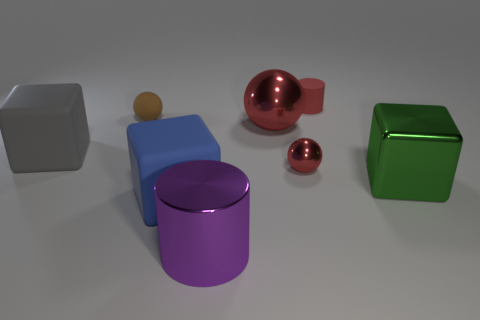There is another ball that is the same color as the tiny metal ball; what is its material?
Keep it short and to the point. Metal. How many gray things are either large metallic cubes or small matte cylinders?
Your response must be concise. 0. There is a large metallic object that is on the right side of the small red shiny thing; is its shape the same as the tiny red thing right of the tiny metallic sphere?
Offer a very short reply. No. How many other things are there of the same material as the small red cylinder?
Your answer should be compact. 3. Are there any blocks that are on the left side of the tiny ball on the left side of the purple object that is on the right side of the small brown ball?
Offer a terse response. Yes. Does the big red sphere have the same material as the green block?
Offer a very short reply. Yes. Are there any other things that are the same shape as the small brown object?
Offer a terse response. Yes. The object left of the tiny ball that is left of the big blue rubber thing is made of what material?
Provide a short and direct response. Rubber. There is a red object behind the small rubber sphere; what is its size?
Keep it short and to the point. Small. There is a large cube that is to the left of the metallic cylinder and right of the large gray rubber cube; what color is it?
Offer a very short reply. Blue. 